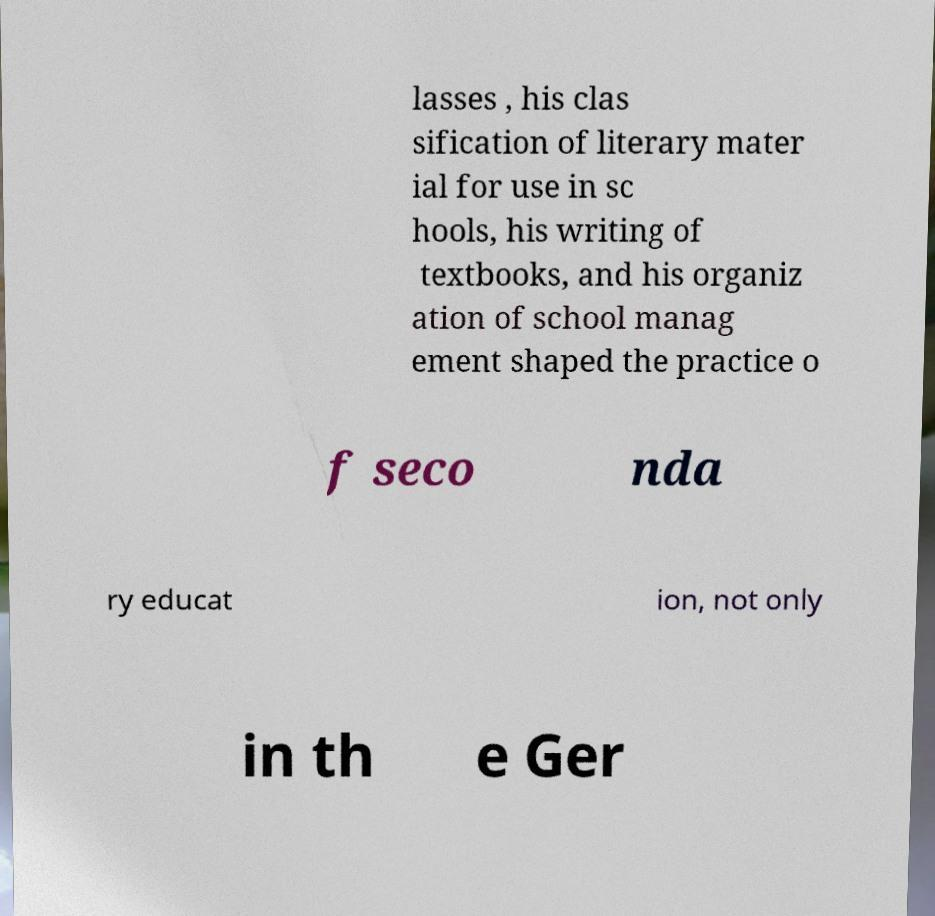Could you assist in decoding the text presented in this image and type it out clearly? lasses , his clas sification of literary mater ial for use in sc hools, his writing of textbooks, and his organiz ation of school manag ement shaped the practice o f seco nda ry educat ion, not only in th e Ger 